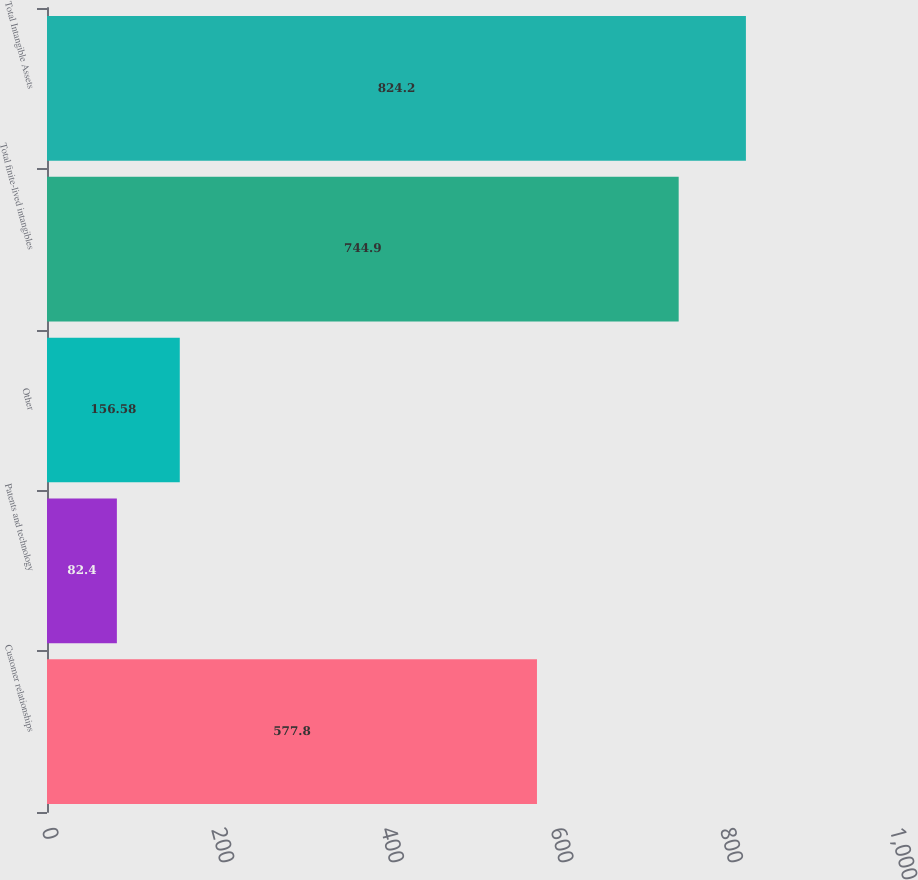Convert chart. <chart><loc_0><loc_0><loc_500><loc_500><bar_chart><fcel>Customer relationships<fcel>Patents and technology<fcel>Other<fcel>Total finite-lived intangibles<fcel>Total Intangible Assets<nl><fcel>577.8<fcel>82.4<fcel>156.58<fcel>744.9<fcel>824.2<nl></chart> 